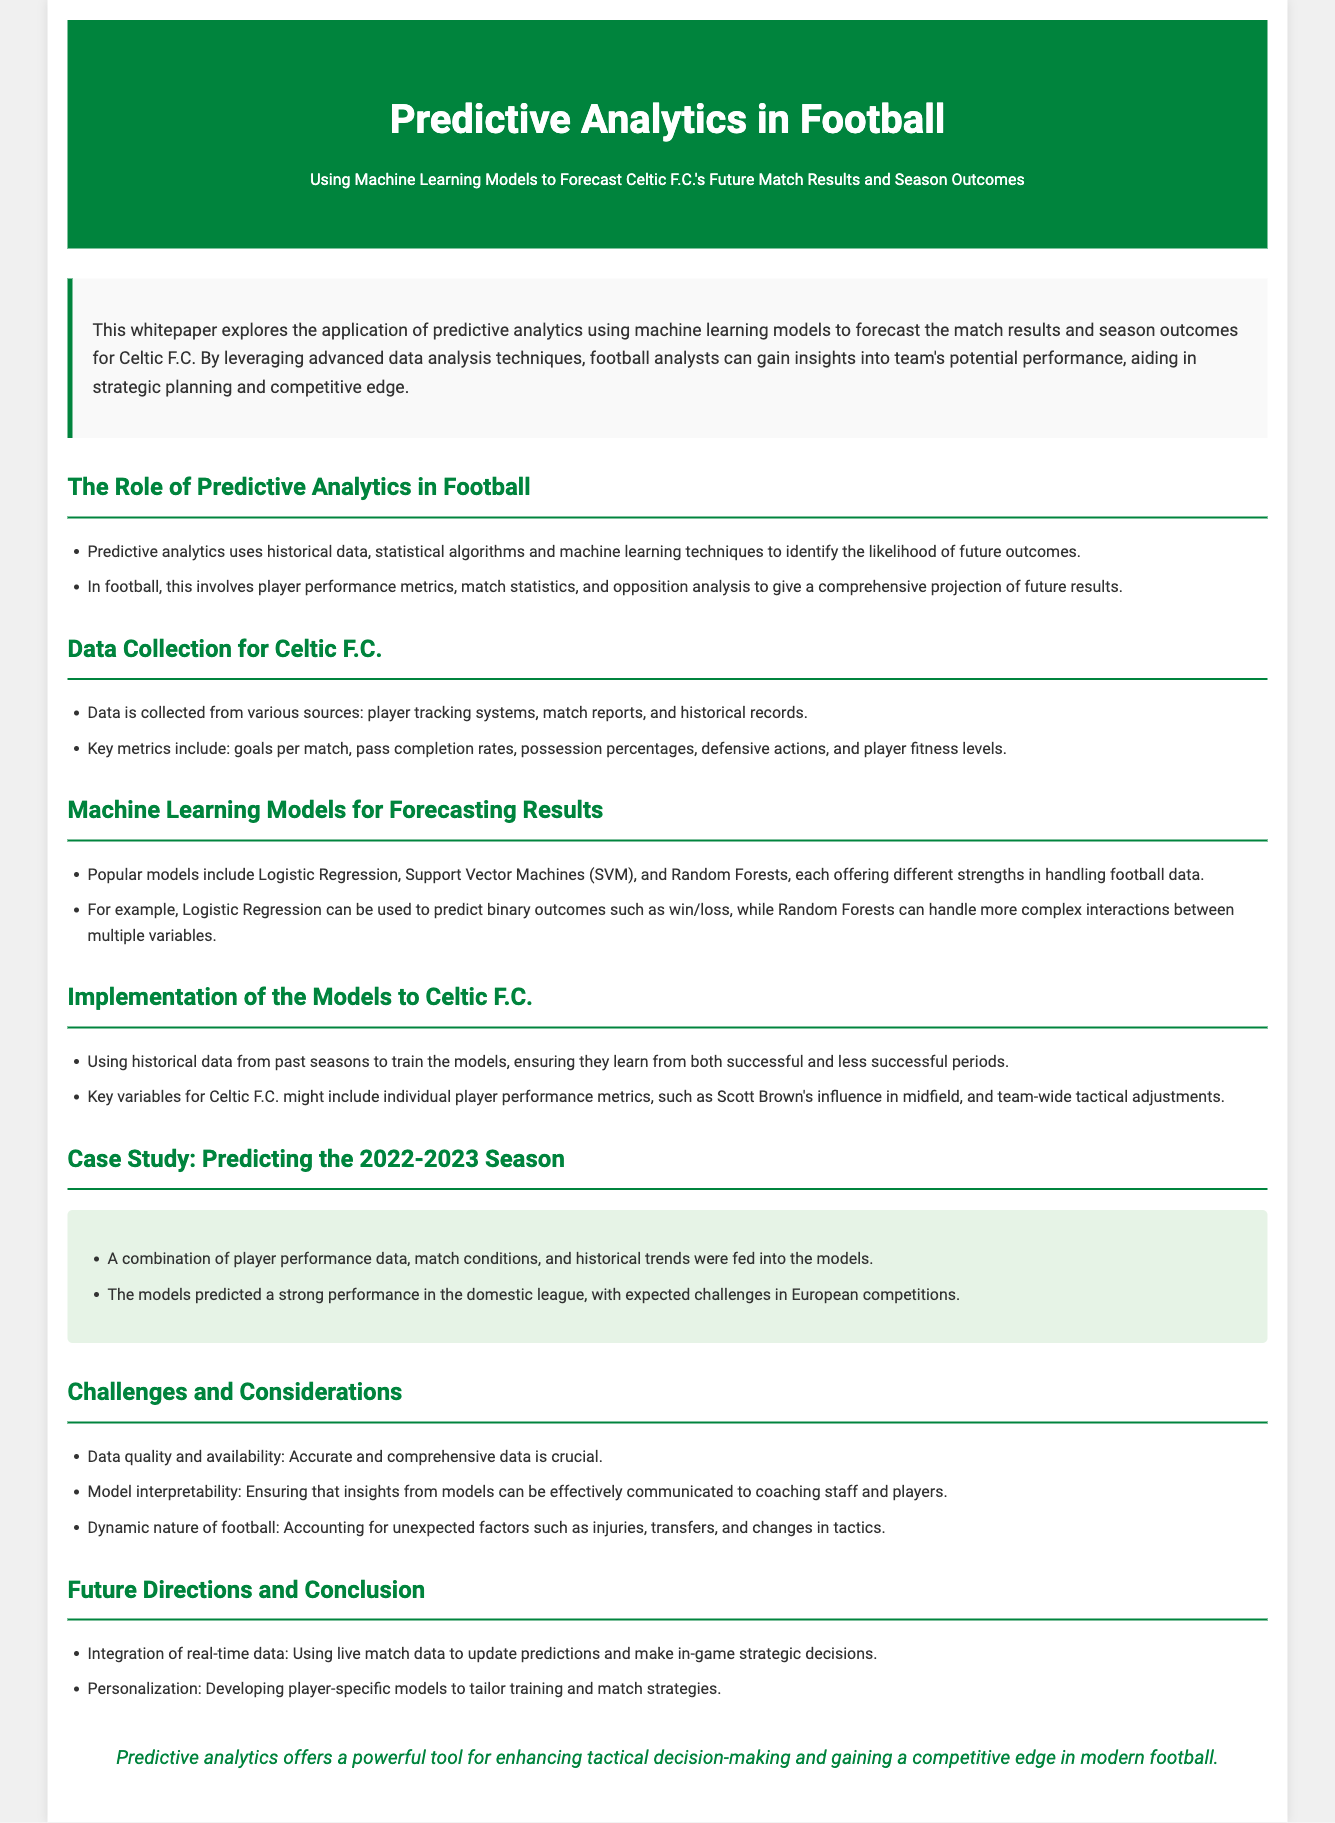what is the title of the whitepaper? The title of the whitepaper is provided in the header section, summarizing the main theme of the document.
Answer: Predictive Analytics in Football: Using Machine Learning Models to Forecast Celtic F.C.'s Future Match Results and Season Outcomes what is the main purpose of the whitepaper? The introduction outlines the objective of the whitepaper, which is to explore how predictive analytics can aid in forecasting match results and season outcomes for Celtic F.C.
Answer: To forecast match results and season outcomes for Celtic F.C which statistical models are mentioned for forecasting results? The section on machine learning models lists popular algorithms used in predictive analytics for football.
Answer: Logistic Regression, Support Vector Machines (SVM), and Random Forests what data sources are mentioned for data collection? The data collection section highlights various sources where data is gathered for analysis.
Answer: Player tracking systems, match reports, and historical records what was predicted for the 2022-2023 season regarding Celtic F.C.? The case study section refers to predictions made about Celtic F.C.'s performance during the season.
Answer: Strong performance in the domestic league, challenges in European competitions name a challenge mentioned in the document? The section on challenges highlights obstacles faced in predictive analytics, focusing on data and model usage.
Answer: Data quality and availability what future direction does the document suggest for predictive analytics? The future directions section proposes enhancements to predictive analytics practices in football.
Answer: Integration of real-time data what is the overall conclusion of the whitepaper? The conclusion summarizes the main takeaway from the document regarding the potential of predictive analytics in football.
Answer: Predictive analytics offers a powerful tool for enhancing tactical decision-making and gaining a competitive edge in modern football 